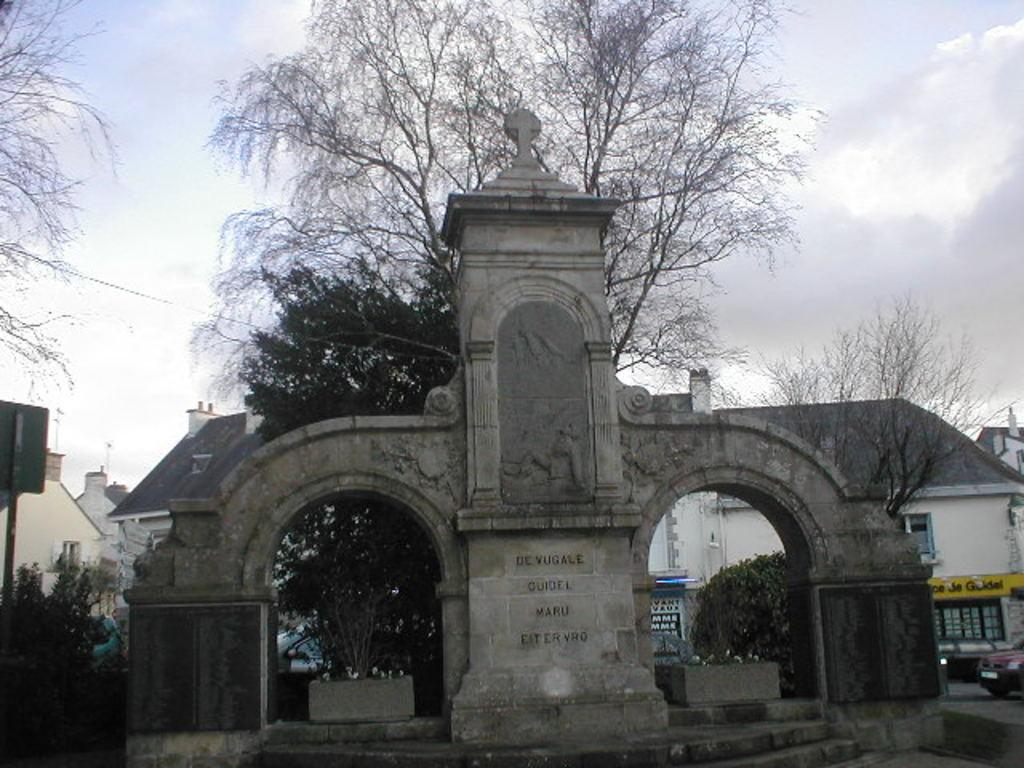What type of structures can be seen in the image? There are buildings in the image. What type of vegetation is present in the image? There are trees in the image. What type of duck can be seen rolling down the street in the image? There is no duck present in the image, and therefore no such activity can be observed. 